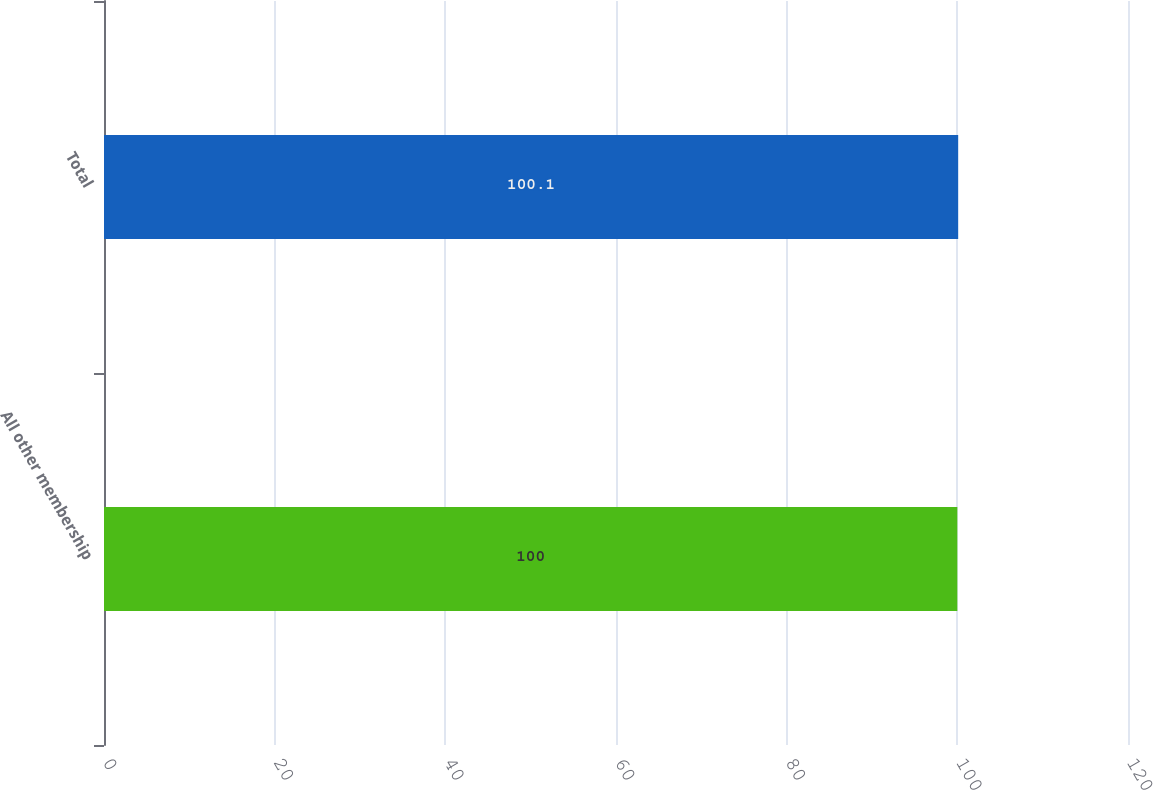Convert chart. <chart><loc_0><loc_0><loc_500><loc_500><bar_chart><fcel>All other membership<fcel>Total<nl><fcel>100<fcel>100.1<nl></chart> 